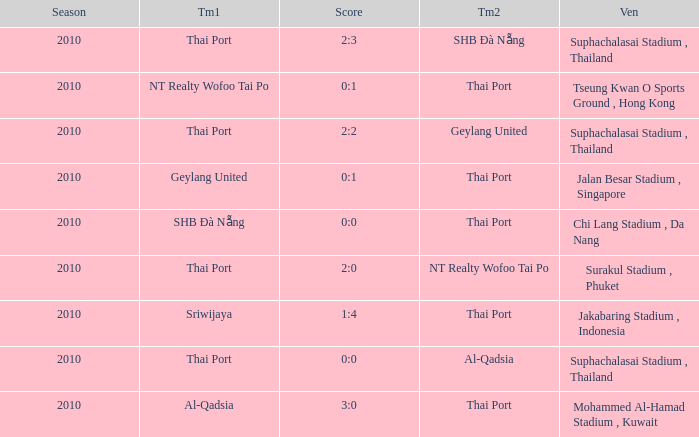Which venue was used for the game whose score was 2:3? Suphachalasai Stadium , Thailand. 